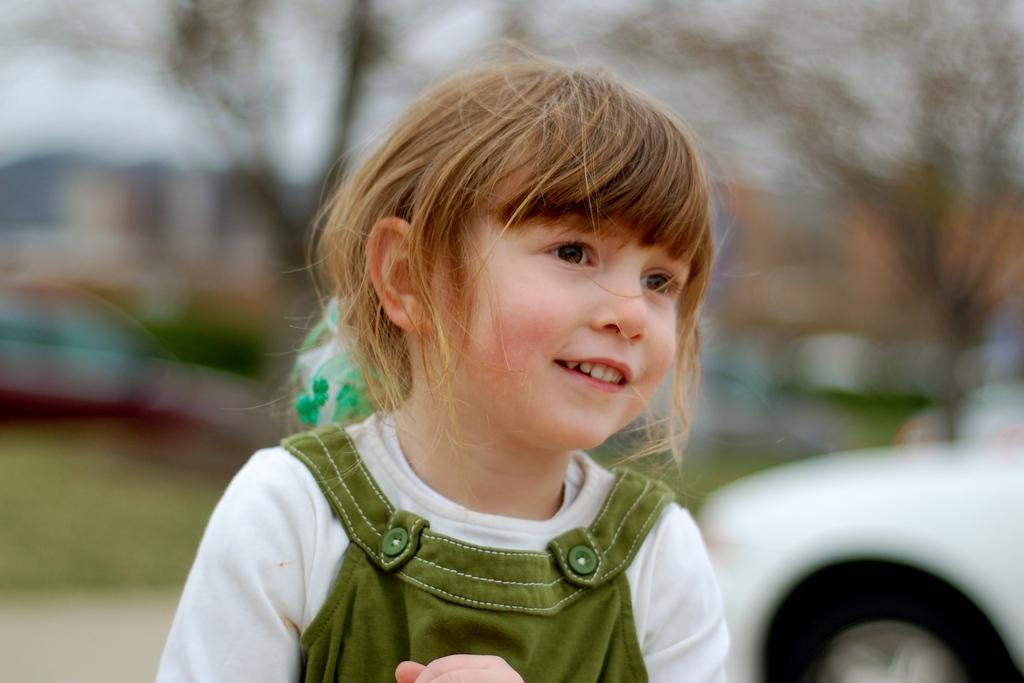Who is the main subject in the image? There is a girl in the image. What else can be seen on the right side of the image? There is a vehicle on the right side of the image. Can you describe the background of the image? The background of the image is blurred. What type of legal advice is the girl providing in the image? There is no indication in the image that the girl is providing legal advice or is a lawyer. 